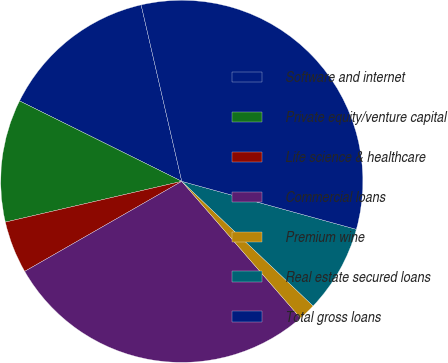Convert chart. <chart><loc_0><loc_0><loc_500><loc_500><pie_chart><fcel>Software and internet<fcel>Private equity/venture capital<fcel>Life science & healthcare<fcel>Commercial loans<fcel>Premium wine<fcel>Real estate secured loans<fcel>Total gross loans<nl><fcel>14.07%<fcel>10.94%<fcel>4.67%<fcel>28.09%<fcel>1.54%<fcel>7.81%<fcel>32.87%<nl></chart> 